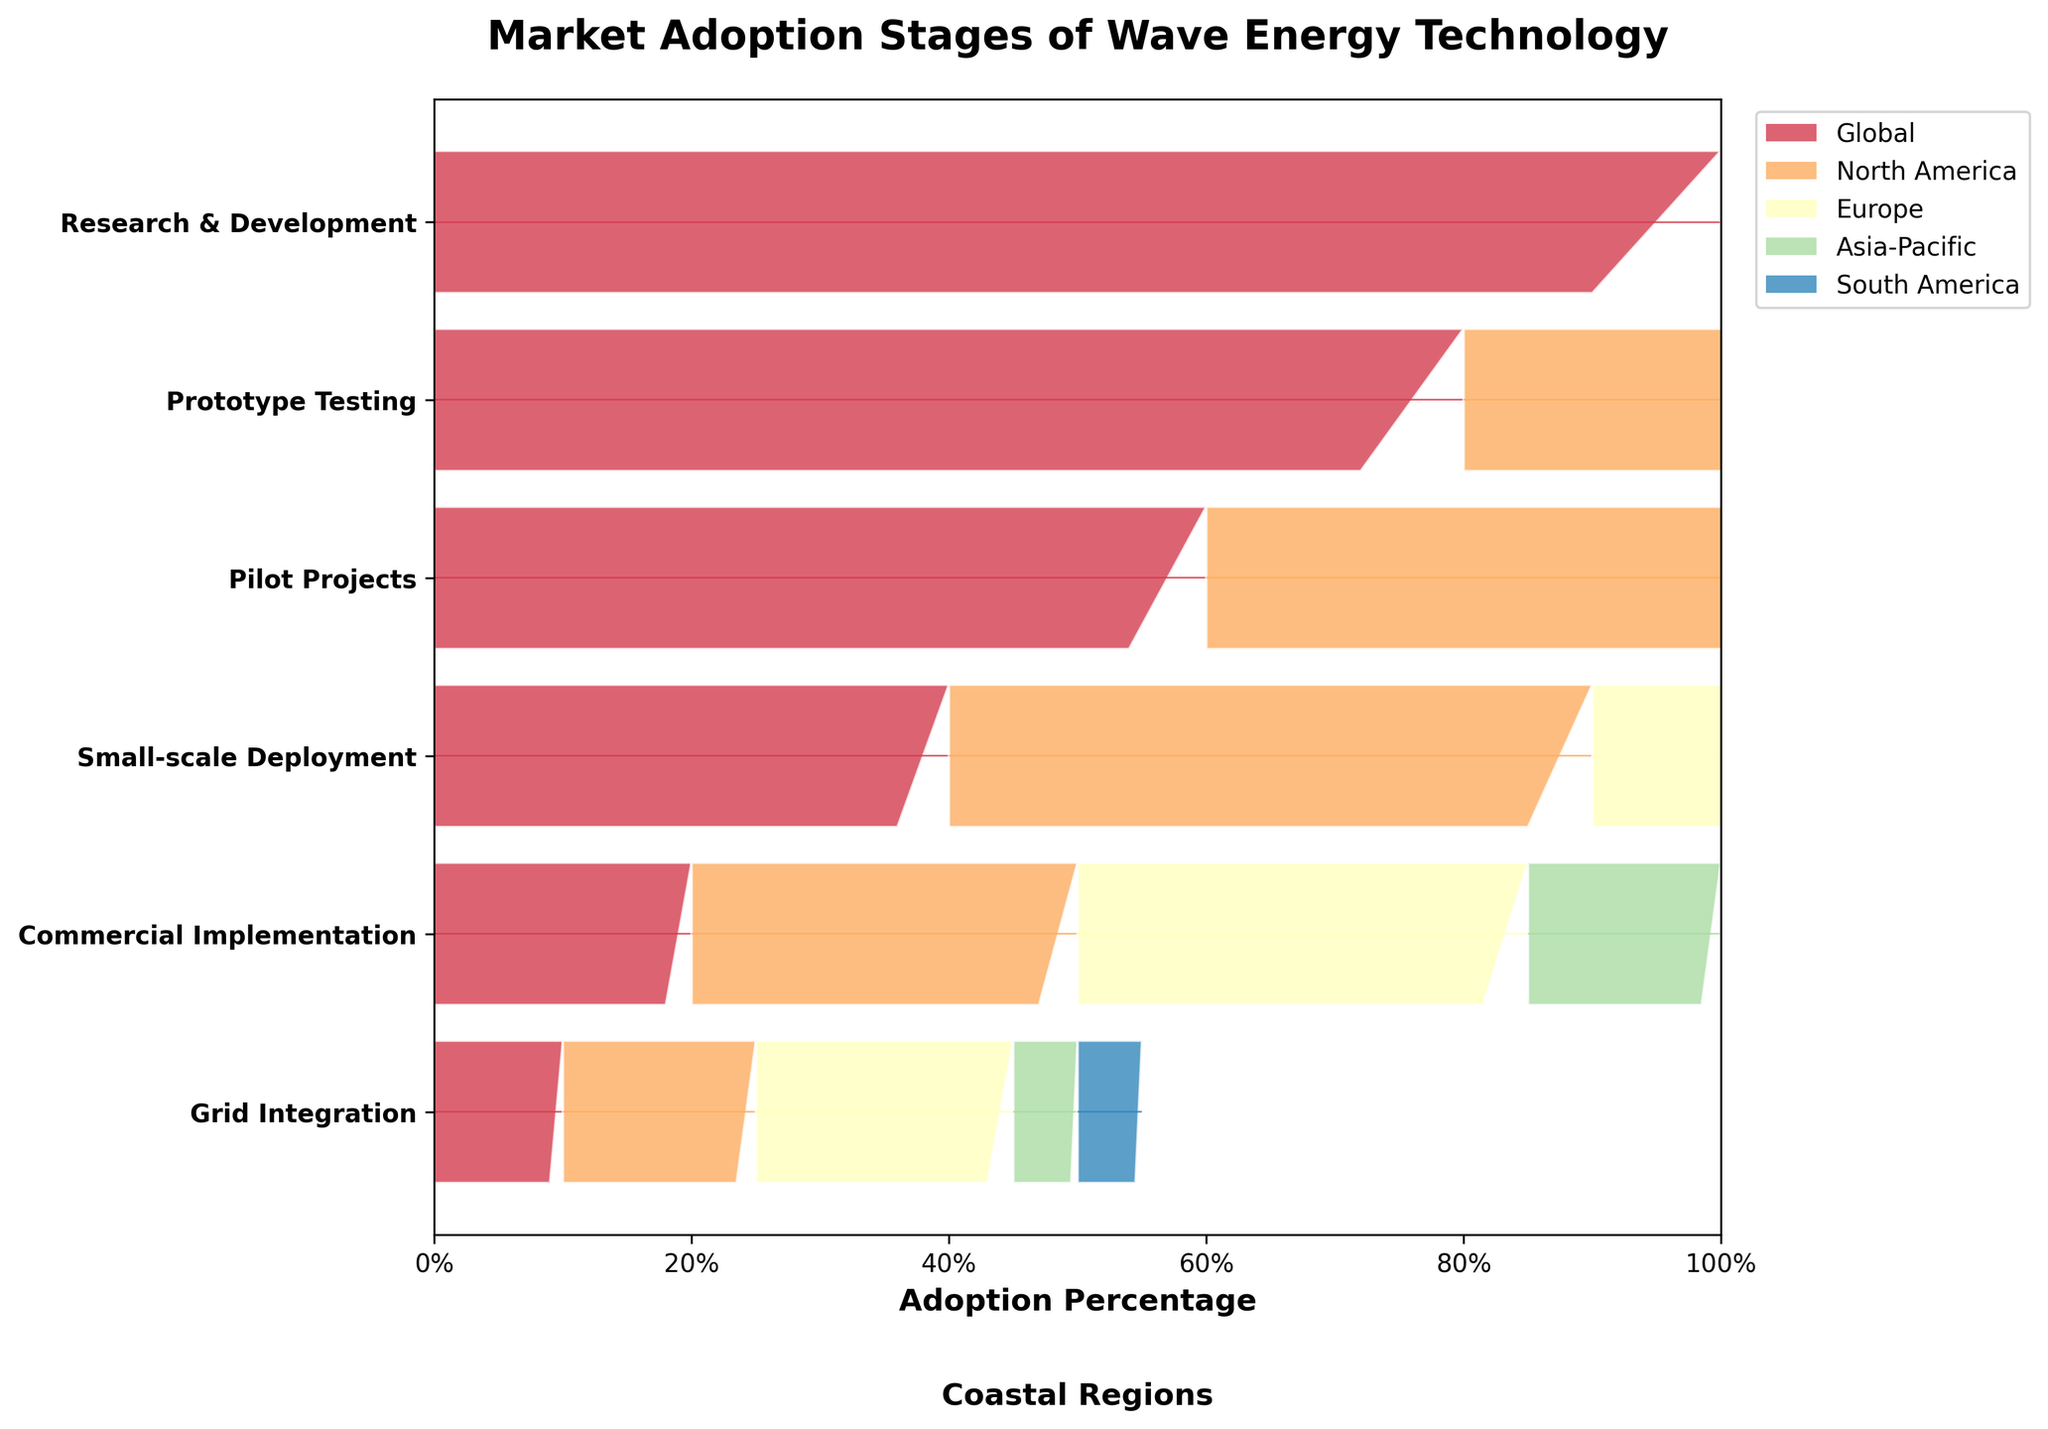What is the title of the figure? The title is found at the top of the figure and states the main focus clearly.
Answer: Market Adoption Stages of Wave Energy Technology Which stage is the least adopted in Asia-Pacific? By looking at the height of each bar segment for Asia-Pacific, the smallest segment represents the least adoption stage.
Answer: Grid Integration How many stages are there in total? Count the number of distinct stages listed on the y-axis.
Answer: Six Which region has the highest percentage of Prototype Testing adoption? Compare the bar segments for Prototype Testing across all regions to find the tallest segment.
Answer: Europe What is the sum of the adoption percentages for North America at the Commercial Implementation and Grid Integration stages? Add the percentages for North America at these two stages: 30% + 15%.
Answer: 45% In which stage is the difference in adoption rate between Europe and South America the greatest? Calculate the differences at each stage and identify the maximum one: 
- Research & Development: 0%
- Prototype Testing: 20%
- Pilot Projects: 25%
- Small-scale Deployment: 30%
- Commercial Implementation: 25%
- Grid Integration: 15%
The greatest difference is at Small-scale Deployment.
Answer: Small-scale Deployment What percentage of adoption is seen in South America during the Research & Development stage? Identify the segment corresponding to South America in the first stage of the funnel chart.
Answer: 100% What is the average adoption percentage for Europe across all stages? Sum the percentages for Europe across all stages and divide by the number of stages:
(100% + 90% + 75% + 60% + 35% + 20%) / 6
Answer: 63.33% In the Commercial Implementation stage, how does North America's adoption compare to Asia-Pacific's? Measure the bar segments for both regions at this stage and see the comparison.
Answer: Greater Which regions have a grid integration adoption percentage of 5%? Look at the Grid Integration stage and find the segments that show a 5% value.
Answer: Asia-Pacific and South America 